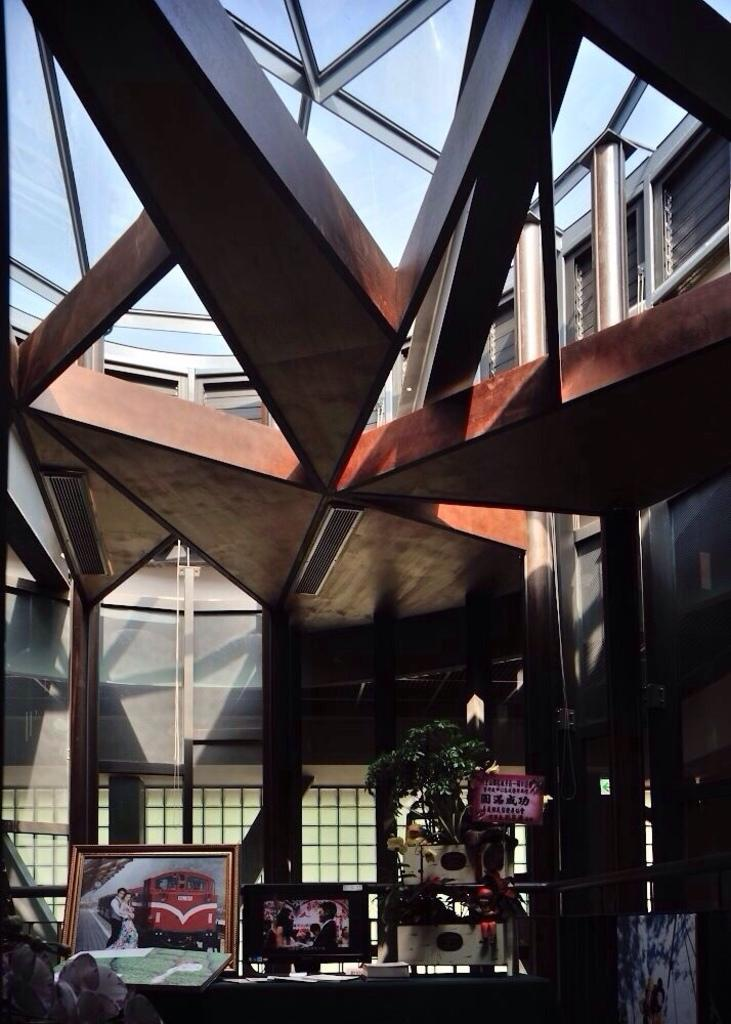What is located at the bottom of the image? There are photo frames and a plant at the bottom of the image. What else can be seen at the bottom of the image? There are other objects present at the bottom of the image. What is visible in the background of the image? There is a glass window in the background of the image. What is located at the top of the image? There are poles and a glass ceiling at the top of the image. Can you tell me how many baby volleyballs are on the glass ceiling in the image? There are no baby volleyballs present in the image, and the glass ceiling does not have any visible objects on it. 